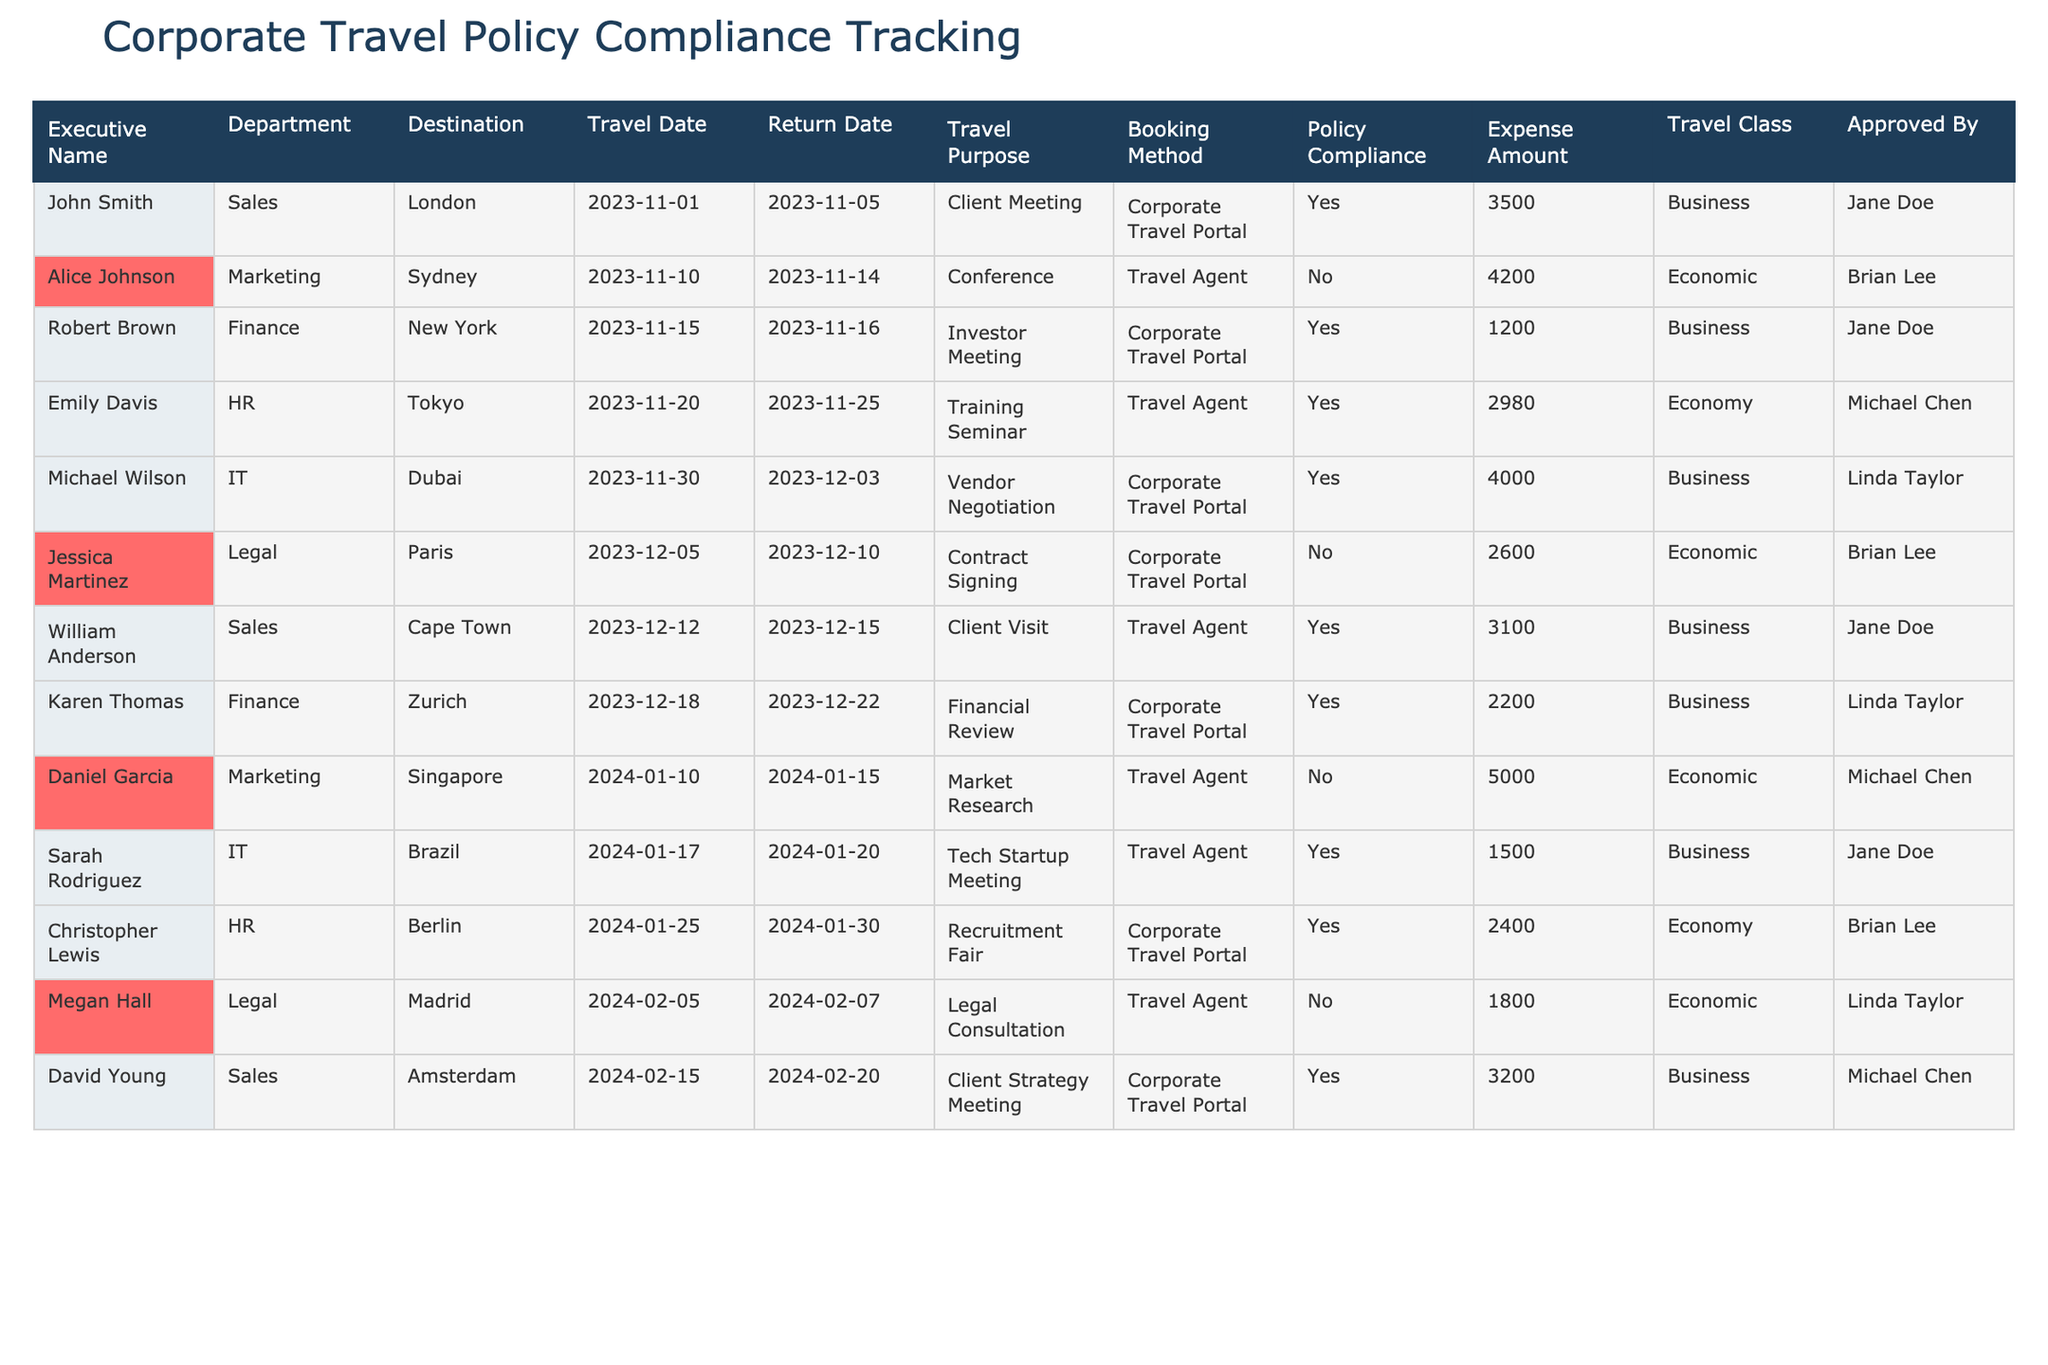What is the total expense amount for all executives traveling to European destinations? The European destinations in the list are London, Paris, Zurich, and Amsterdam. The corresponding expense amounts are 3500, 2600, 2200, and 3200 respectively. Summing these gives (3500 + 2600 + 2200 + 3200) = 11500.
Answer: 11500 How many executives booked their travel through the Corporate Travel Portal? The executives who booked through the Corporate Travel Portal are John Smith, Robert Brown, Michael Wilson, Karen Thomas, Christopher Lewis, and David Young. This totals to 6 executives.
Answer: 6 Did any executive travel to a destination for a conference? Yes, Alice Johnson traveled to Sydney for a conference, as indicated by the travel purpose in the table.
Answer: Yes Which department had the highest total expense for travel, and what was the amount? To find the department with the highest total expense, we sum the expenses per department: Sales (3500 + 3100 + 3200 = 9800), Marketing (4200 + 5000 = 9200), Finance (1200 + 2200 = 3400), HR (2980 + 2400 = 5380), IT (4000 + 1500 = 5500), Legal (2600 + 1800 = 4400). Sales has the highest sum of 9800.
Answer: Sales, 9800 What percentage of trips were compliant with the corporate travel policy? There are 12 total trips; 8 of them are compliant (marked 'Yes'). To find the percentage, we calculate (8 / 12) * 100 = 66.67%.
Answer: 66.67% Who approved the most travel requests, and how many did they approve? The approvers are Jane Doe (3), Brian Lee (3), Linda Taylor (2), and Michael Chen (2). Jane Doe and Brian Lee both approved the most requests, with 3 each.
Answer: Jane Doe and Brian Lee, 3 each Is there any executive who had a travel expense amount greater than 4000? Yes, Alice Johnson's travel expense to Sydney was 4200, which is greater than 4000.
Answer: Yes What travel class was most commonly booked by executives traveling for client meetings? The travel classes for client meetings are Business (John Smith and David Young) and Economic (William Anderson). Business is more common as 2 out of 3 travel requests were booked in this class.
Answer: Business 